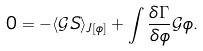<formula> <loc_0><loc_0><loc_500><loc_500>0 = - \langle \mathcal { G } S \rangle _ { J [ \phi ] } + \int \frac { \delta \Gamma } { \delta \phi } \mathcal { G } \phi .</formula> 